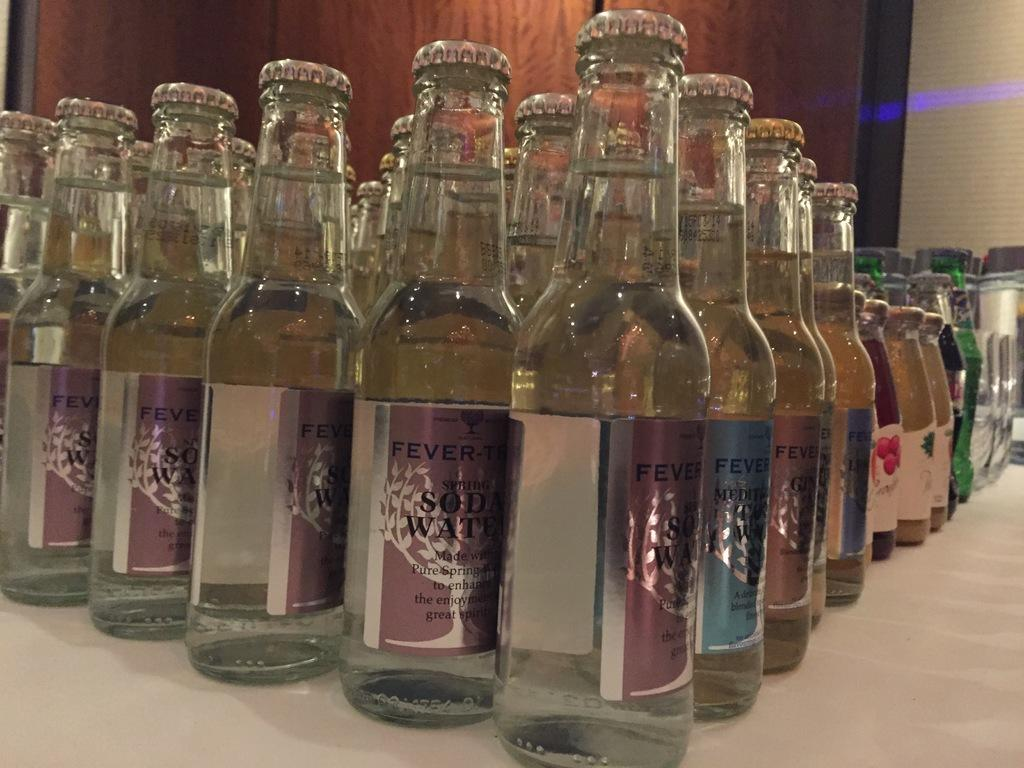<image>
Summarize the visual content of the image. Several bottle of Fever Tree Soda Water lined up on a table. 